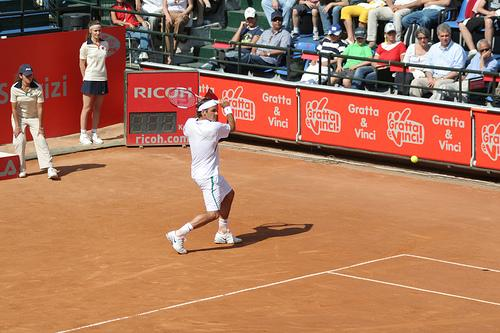Why is the man swinging his arms? hit ball 